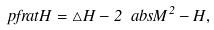Convert formula to latex. <formula><loc_0><loc_0><loc_500><loc_500>\ p f r a { t } H = \triangle H - 2 \ a b s { M } ^ { 2 } - H ,</formula> 